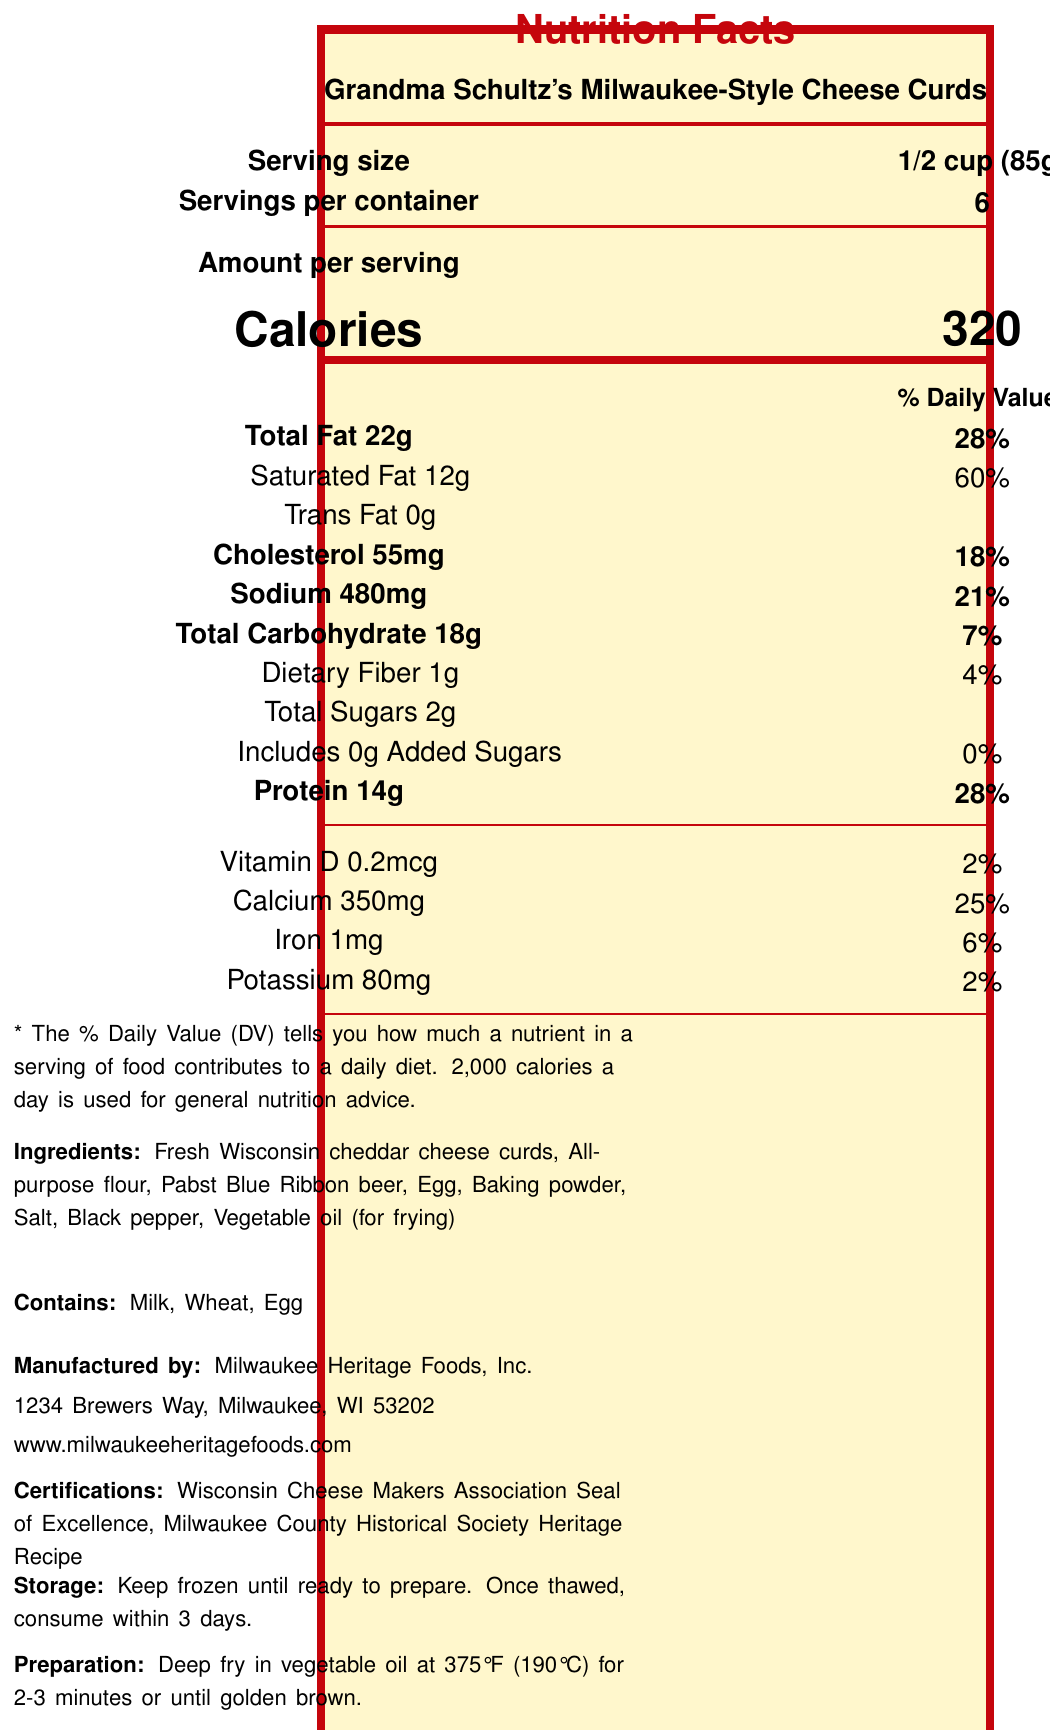what is the serving size of Grandma Schultz's Milwaukee-Style Cheese Curds? The serving size is explicitly stated in the Nutrition Facts label.
Answer: 1/2 cup (85g) how many calories are in one serving? The number of calories per serving is listed as 320 in the document.
Answer: 320 what is the main ingredient in Grandma Schultz's Milwaukee-Style Cheese Curds? The first ingredient listed is Fresh Wisconsin cheddar cheese curds, which typically indicates it is the main ingredient.
Answer: Fresh Wisconsin cheddar cheese curds how much saturated fat is in a serving? The amount of saturated fat per serving is clearly indicated on the label as 12g.
Answer: 12g what desserts are these cheese curds a good source of? The document provides nutrition information but does not specify any desserts or how the cheese curds are used.
Answer: Cannot be determined what is the percentage of daily value for sodium in one serving? A. 18% B. 21% C. 25% The document states that the sodium daily value percentage per serving is 21%.
Answer: B. 21% which vitamin has the lowest daily value percentage in this product? A. Vitamin D B. Calcium C. Iron D. Potassium Vitamin D has the lowest daily value percentage at 2% among the vitamins and minerals listed.
Answer: A. Vitamin D does this product contain any added sugars? The label shows 0g of added sugars indicating that there are no added sugars in this product.
Answer: No is this product fried or baked according to the preparation method? The preparation method specifies deep frying in vegetable oil at 375°F.
Answer: Fried what certifications does this product have? The certifications are listed explicitly in the document.
Answer: Wisconsin Cheese Makers Association Seal of Excellence, Milwaukee County Historical Society Heritage Recipe describe the nutritional information for Grandma Schultz's Milwaukee-Style Cheese Curds. The summary includes all major nutritional details provided by the label.
Answer: The nutritional information for Grandma Schultz's Milwaukee-Style Cheese Curds includes a serving size of 1/2 cup (85g), with 320 calories per serving. It contains 22g of total fat (28% DV), including 12g of saturated fat (60% DV) and no trans fat. There is 55mg of cholesterol (18% DV) and 480mg of sodium (21% DV). Each serving has 18g of total carbohydrates (7% DV), 1g of dietary fiber (4% DV), 2g of total sugars with no added sugars, and 14g of protein (28% DV). Additionally, it provides 2% DV of Vitamin D, 25% DV of calcium, 6% DV of iron, and 2% DV of potassium. how many servings are there in this container? The servings per container are mentioned as 6 on the document.
Answer: 6 which allergens are present in this product? The listed allergens in the document are Milk, Wheat, and Egg.
Answer: Milk, Wheat, Egg how many grams of total carbohydrate are in one serving? The label indicates that one serving contains 18g of total carbohydrate.
Answer: 18g if you consume two servings of this product, how much protein would you ingest? There are 14g of protein per serving, so consuming two servings would result in 28g of protein.
Answer: 28g what is included in the ingredients list? All these ingredients are clearly listed in the ingredients section of the document.
Answer: Fresh Wisconsin cheddar cheese curds, All-purpose flour, Pabst Blue Ribbon beer, Egg, Baking powder, Salt, Black pepper, Vegetable oil (for frying) what is the sustainability note related to this product? The sustainability note mentions that the packaging is made from 100% recycled materials from Milwaukee's paper recycling program.
Answer: Packaging made from 100% recycled materials sourced from Milwaukee's paper recycling program. 